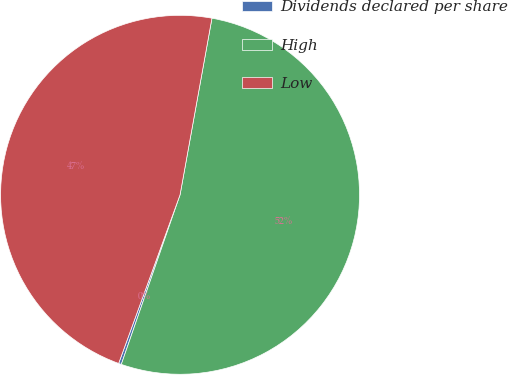<chart> <loc_0><loc_0><loc_500><loc_500><pie_chart><fcel>Dividends declared per share<fcel>High<fcel>Low<nl><fcel>0.25%<fcel>52.47%<fcel>47.29%<nl></chart> 